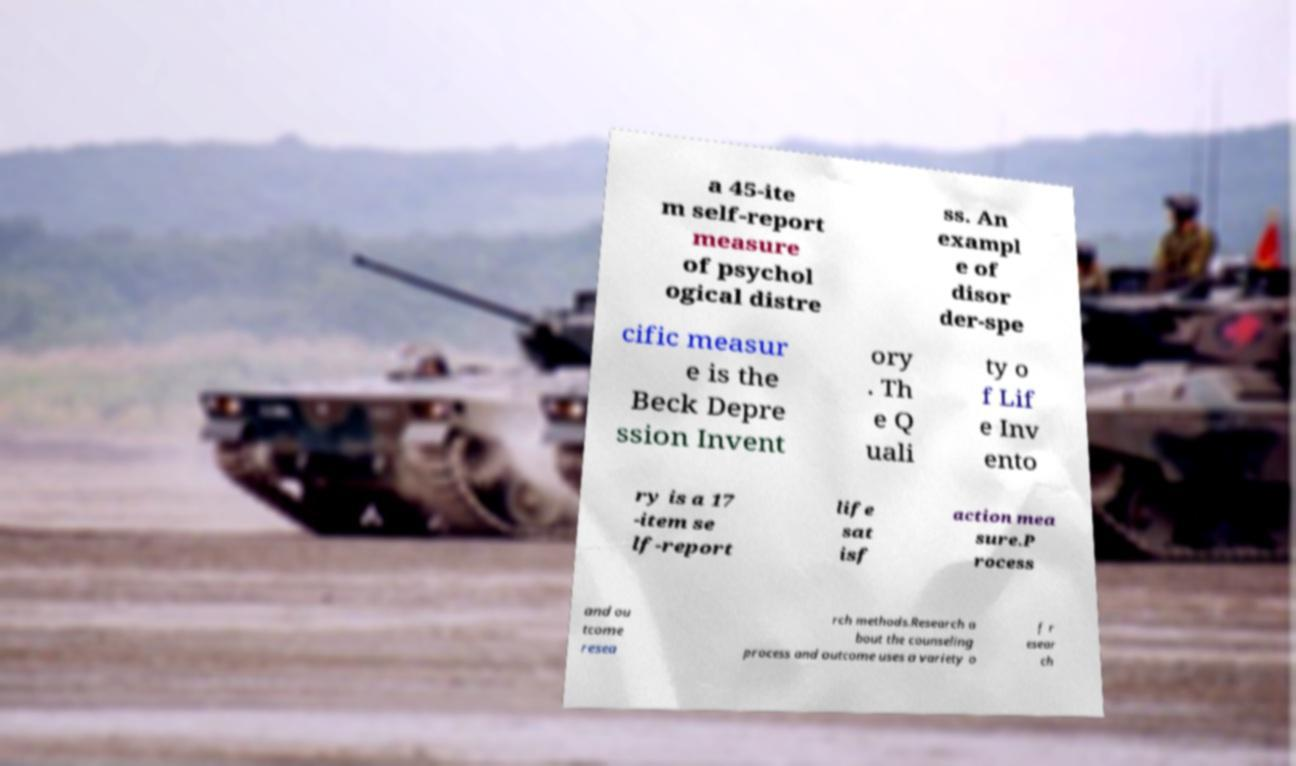Can you accurately transcribe the text from the provided image for me? a 45-ite m self-report measure of psychol ogical distre ss. An exampl e of disor der-spe cific measur e is the Beck Depre ssion Invent ory . Th e Q uali ty o f Lif e Inv ento ry is a 17 -item se lf-report life sat isf action mea sure.P rocess and ou tcome resea rch methods.Research a bout the counseling process and outcome uses a variety o f r esear ch 